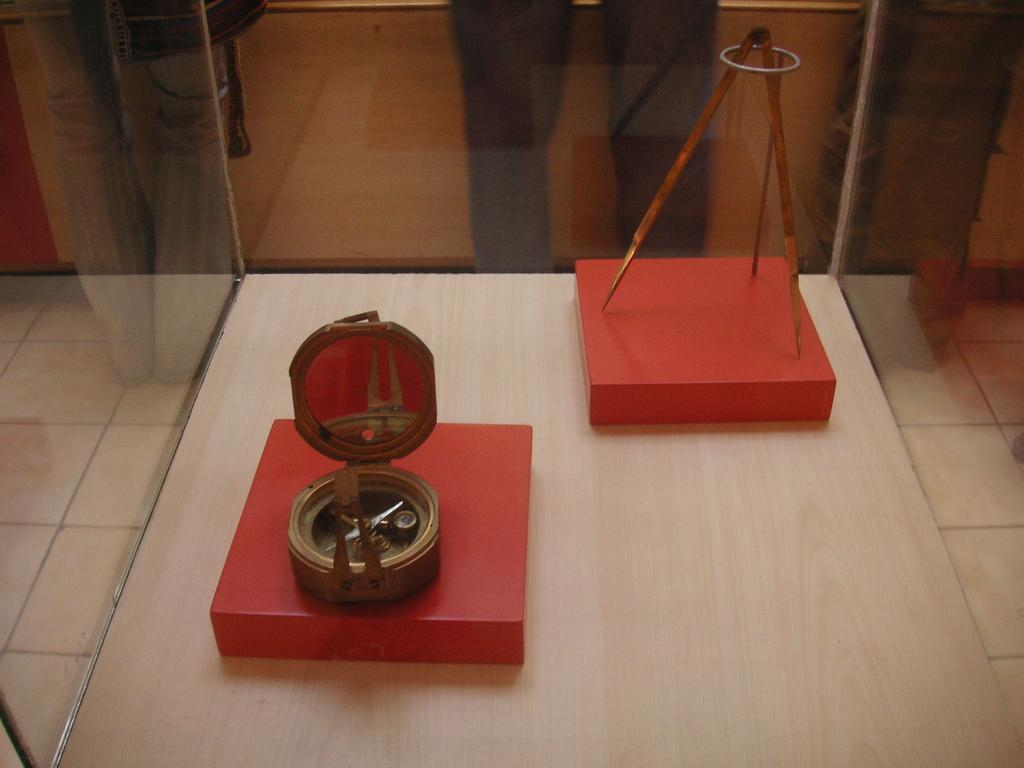What is the main structure in the image? There is a glass box in the image. What can be found inside the glass box? There are objects inside the glass box. What type of surface is visible in the image? The image shows a floor. Are there any people present in the image? Yes, there are people standing in the image. How are the people dressed in the image? The people are wearing clothes. What type of advertisement can be seen on the van in the image? There is no van present in the image, so it is not possible to answer that question. 